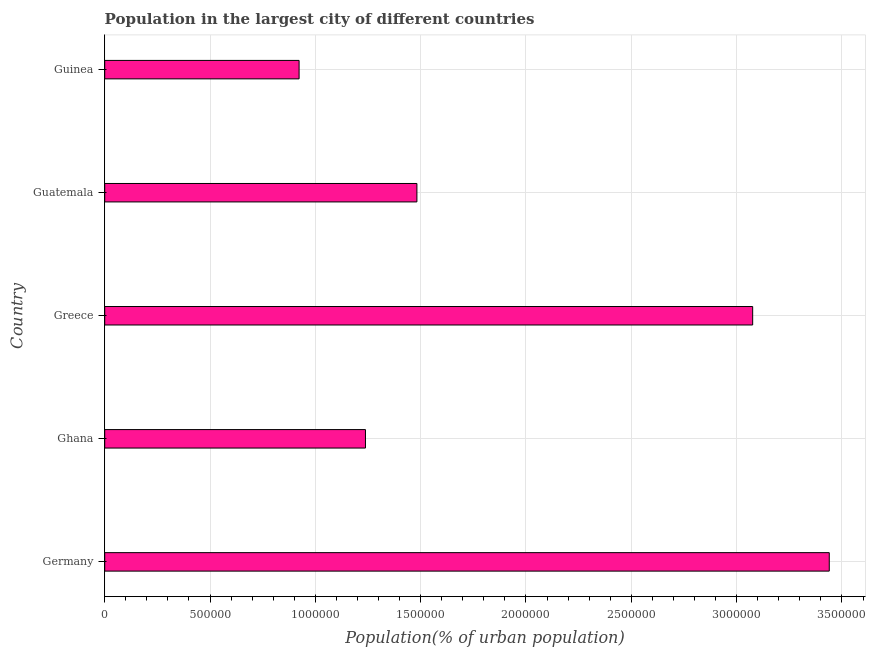Does the graph contain any zero values?
Your answer should be compact. No. What is the title of the graph?
Make the answer very short. Population in the largest city of different countries. What is the label or title of the X-axis?
Your response must be concise. Population(% of urban population). What is the label or title of the Y-axis?
Keep it short and to the point. Country. What is the population in largest city in Germany?
Provide a short and direct response. 3.44e+06. Across all countries, what is the maximum population in largest city?
Keep it short and to the point. 3.44e+06. Across all countries, what is the minimum population in largest city?
Your answer should be compact. 9.23e+05. In which country was the population in largest city maximum?
Make the answer very short. Germany. In which country was the population in largest city minimum?
Your answer should be compact. Guinea. What is the sum of the population in largest city?
Keep it short and to the point. 1.02e+07. What is the difference between the population in largest city in Greece and Guatemala?
Ensure brevity in your answer.  1.59e+06. What is the average population in largest city per country?
Give a very brief answer. 2.03e+06. What is the median population in largest city?
Your response must be concise. 1.48e+06. In how many countries, is the population in largest city greater than 1900000 %?
Provide a short and direct response. 2. What is the ratio of the population in largest city in Germany to that in Ghana?
Ensure brevity in your answer.  2.78. Is the population in largest city in Germany less than that in Guinea?
Give a very brief answer. No. What is the difference between the highest and the second highest population in largest city?
Provide a succinct answer. 3.64e+05. What is the difference between the highest and the lowest population in largest city?
Keep it short and to the point. 2.52e+06. In how many countries, is the population in largest city greater than the average population in largest city taken over all countries?
Your response must be concise. 2. How many bars are there?
Give a very brief answer. 5. How many countries are there in the graph?
Your response must be concise. 5. Are the values on the major ticks of X-axis written in scientific E-notation?
Keep it short and to the point. No. What is the Population(% of urban population) in Germany?
Provide a succinct answer. 3.44e+06. What is the Population(% of urban population) of Ghana?
Keep it short and to the point. 1.24e+06. What is the Population(% of urban population) of Greece?
Make the answer very short. 3.08e+06. What is the Population(% of urban population) in Guatemala?
Make the answer very short. 1.48e+06. What is the Population(% of urban population) of Guinea?
Your answer should be very brief. 9.23e+05. What is the difference between the Population(% of urban population) in Germany and Ghana?
Keep it short and to the point. 2.20e+06. What is the difference between the Population(% of urban population) in Germany and Greece?
Offer a terse response. 3.64e+05. What is the difference between the Population(% of urban population) in Germany and Guatemala?
Provide a short and direct response. 1.96e+06. What is the difference between the Population(% of urban population) in Germany and Guinea?
Your response must be concise. 2.52e+06. What is the difference between the Population(% of urban population) in Ghana and Greece?
Keep it short and to the point. -1.84e+06. What is the difference between the Population(% of urban population) in Ghana and Guatemala?
Give a very brief answer. -2.44e+05. What is the difference between the Population(% of urban population) in Ghana and Guinea?
Ensure brevity in your answer.  3.15e+05. What is the difference between the Population(% of urban population) in Greece and Guatemala?
Keep it short and to the point. 1.59e+06. What is the difference between the Population(% of urban population) in Greece and Guinea?
Provide a succinct answer. 2.15e+06. What is the difference between the Population(% of urban population) in Guatemala and Guinea?
Make the answer very short. 5.59e+05. What is the ratio of the Population(% of urban population) in Germany to that in Ghana?
Your answer should be very brief. 2.78. What is the ratio of the Population(% of urban population) in Germany to that in Greece?
Make the answer very short. 1.12. What is the ratio of the Population(% of urban population) in Germany to that in Guatemala?
Your answer should be very brief. 2.32. What is the ratio of the Population(% of urban population) in Germany to that in Guinea?
Ensure brevity in your answer.  3.73. What is the ratio of the Population(% of urban population) in Ghana to that in Greece?
Your answer should be very brief. 0.4. What is the ratio of the Population(% of urban population) in Ghana to that in Guatemala?
Make the answer very short. 0.83. What is the ratio of the Population(% of urban population) in Ghana to that in Guinea?
Provide a succinct answer. 1.34. What is the ratio of the Population(% of urban population) in Greece to that in Guatemala?
Offer a very short reply. 2.08. What is the ratio of the Population(% of urban population) in Greece to that in Guinea?
Keep it short and to the point. 3.33. What is the ratio of the Population(% of urban population) in Guatemala to that in Guinea?
Your response must be concise. 1.61. 